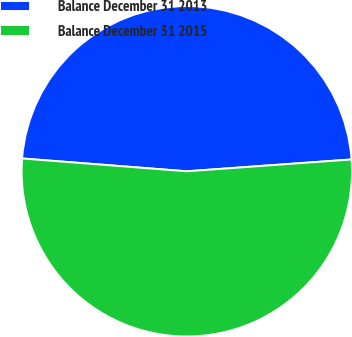<chart> <loc_0><loc_0><loc_500><loc_500><pie_chart><fcel>Balance December 31 2013<fcel>Balance December 31 2015<nl><fcel>47.62%<fcel>52.38%<nl></chart> 